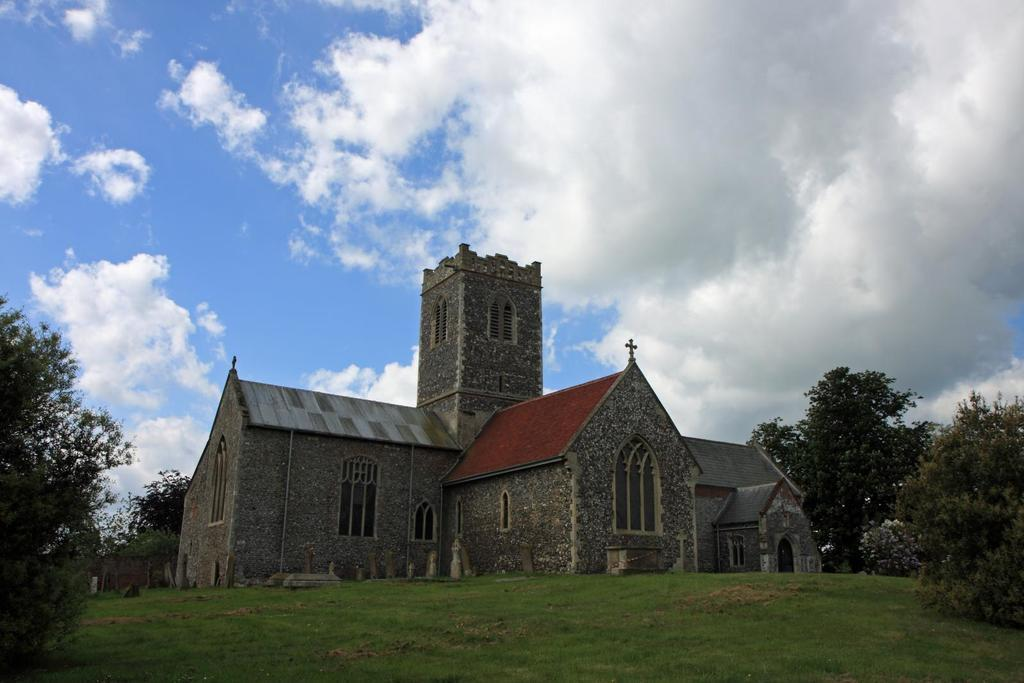What is the main subject in the center of the image? There is a building in the center of the image. What type of vegetation can be seen at the bottom of the image? There is grass and trees at the bottom of the image. What can be seen in the background of the image? Trees and the sky are visible in the background of the image. What is the condition of the sky in the background? Clouds are present in the background of the image. What type of organization is responsible for the camera in the image? There is no camera present in the image, so it is not possible to determine which organization might be responsible for it. 